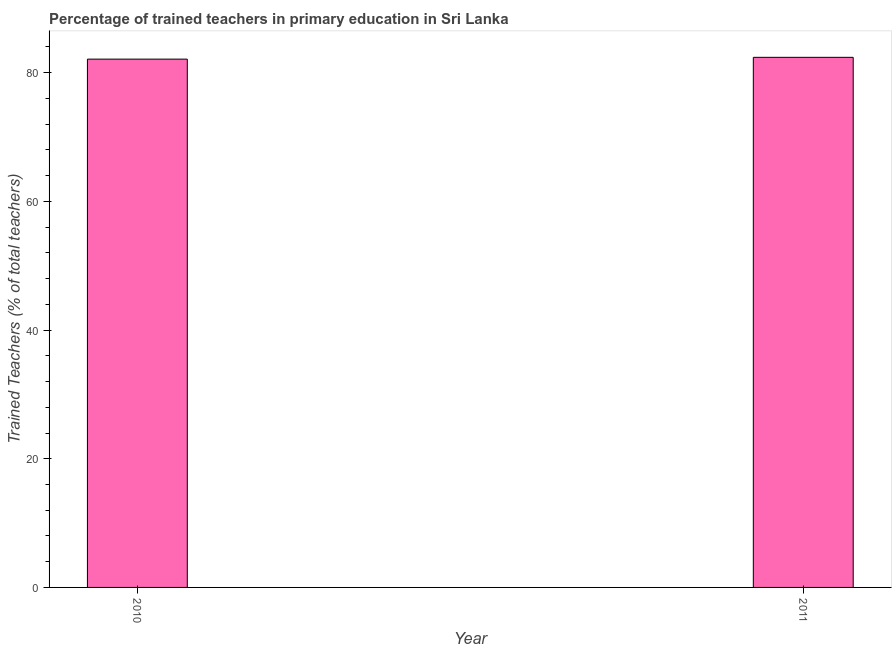Does the graph contain grids?
Ensure brevity in your answer.  No. What is the title of the graph?
Provide a succinct answer. Percentage of trained teachers in primary education in Sri Lanka. What is the label or title of the Y-axis?
Offer a terse response. Trained Teachers (% of total teachers). What is the percentage of trained teachers in 2010?
Keep it short and to the point. 82.11. Across all years, what is the maximum percentage of trained teachers?
Make the answer very short. 82.39. Across all years, what is the minimum percentage of trained teachers?
Your response must be concise. 82.11. What is the sum of the percentage of trained teachers?
Offer a terse response. 164.5. What is the difference between the percentage of trained teachers in 2010 and 2011?
Keep it short and to the point. -0.28. What is the average percentage of trained teachers per year?
Provide a succinct answer. 82.25. What is the median percentage of trained teachers?
Provide a succinct answer. 82.25. Do a majority of the years between 2011 and 2010 (inclusive) have percentage of trained teachers greater than 16 %?
Make the answer very short. No. In how many years, is the percentage of trained teachers greater than the average percentage of trained teachers taken over all years?
Give a very brief answer. 1. Are all the bars in the graph horizontal?
Provide a short and direct response. No. How many years are there in the graph?
Provide a succinct answer. 2. What is the difference between two consecutive major ticks on the Y-axis?
Ensure brevity in your answer.  20. What is the Trained Teachers (% of total teachers) of 2010?
Give a very brief answer. 82.11. What is the Trained Teachers (% of total teachers) of 2011?
Provide a succinct answer. 82.39. What is the difference between the Trained Teachers (% of total teachers) in 2010 and 2011?
Give a very brief answer. -0.28. What is the ratio of the Trained Teachers (% of total teachers) in 2010 to that in 2011?
Offer a very short reply. 1. 